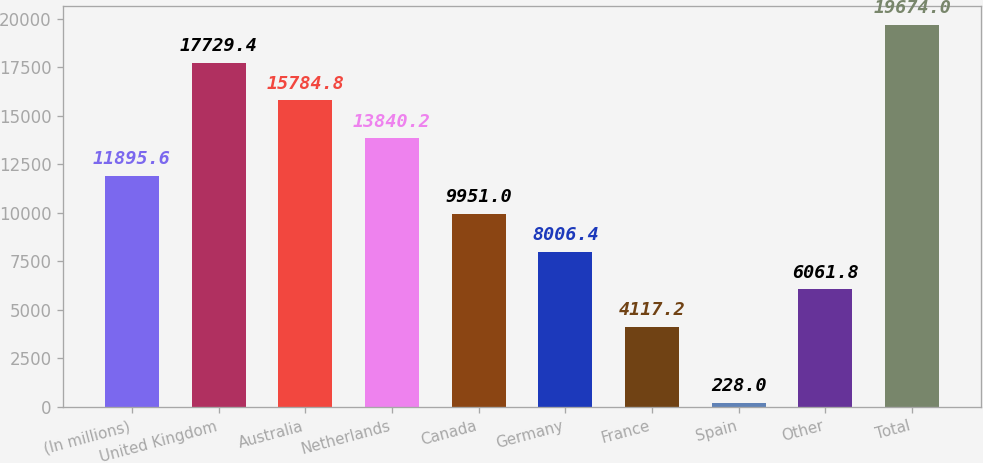Convert chart to OTSL. <chart><loc_0><loc_0><loc_500><loc_500><bar_chart><fcel>(In millions)<fcel>United Kingdom<fcel>Australia<fcel>Netherlands<fcel>Canada<fcel>Germany<fcel>France<fcel>Spain<fcel>Other<fcel>Total<nl><fcel>11895.6<fcel>17729.4<fcel>15784.8<fcel>13840.2<fcel>9951<fcel>8006.4<fcel>4117.2<fcel>228<fcel>6061.8<fcel>19674<nl></chart> 